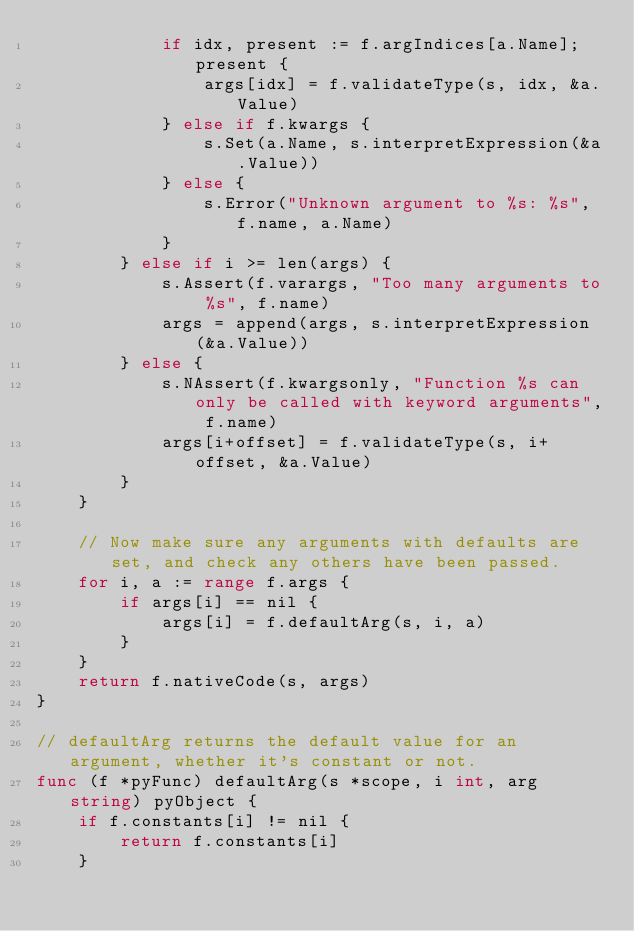<code> <loc_0><loc_0><loc_500><loc_500><_Go_>			if idx, present := f.argIndices[a.Name]; present {
				args[idx] = f.validateType(s, idx, &a.Value)
			} else if f.kwargs {
				s.Set(a.Name, s.interpretExpression(&a.Value))
			} else {
				s.Error("Unknown argument to %s: %s", f.name, a.Name)
			}
		} else if i >= len(args) {
			s.Assert(f.varargs, "Too many arguments to %s", f.name)
			args = append(args, s.interpretExpression(&a.Value))
		} else {
			s.NAssert(f.kwargsonly, "Function %s can only be called with keyword arguments", f.name)
			args[i+offset] = f.validateType(s, i+offset, &a.Value)
		}
	}

	// Now make sure any arguments with defaults are set, and check any others have been passed.
	for i, a := range f.args {
		if args[i] == nil {
			args[i] = f.defaultArg(s, i, a)
		}
	}
	return f.nativeCode(s, args)
}

// defaultArg returns the default value for an argument, whether it's constant or not.
func (f *pyFunc) defaultArg(s *scope, i int, arg string) pyObject {
	if f.constants[i] != nil {
		return f.constants[i]
	}</code> 